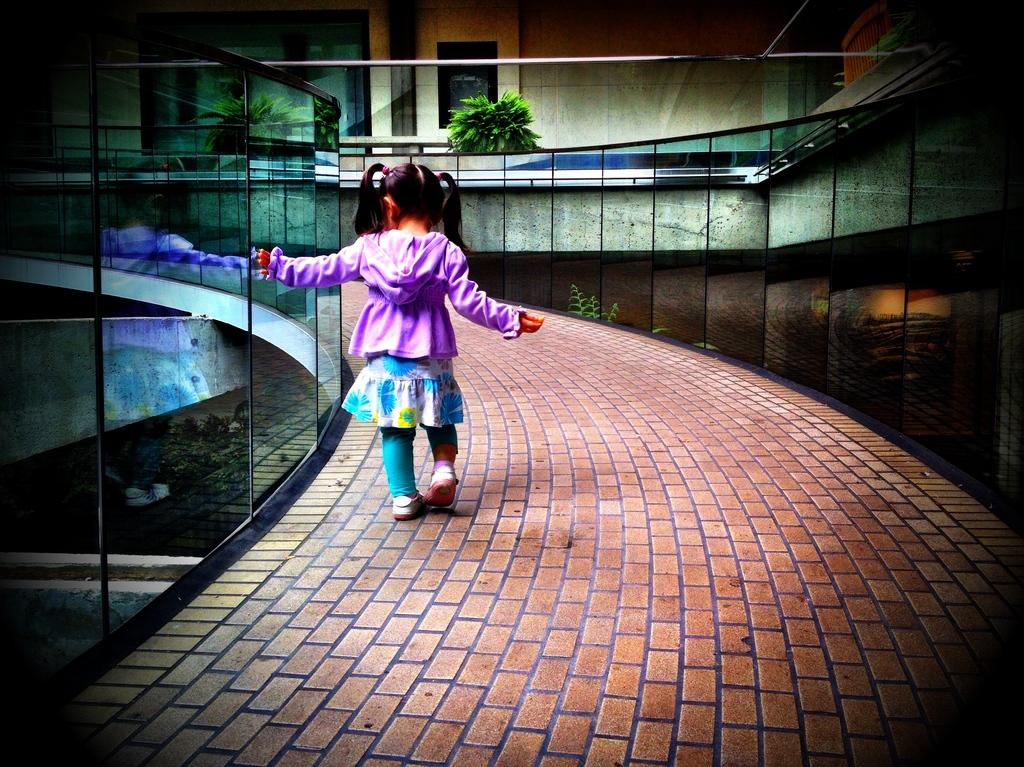What is the girl in the image doing? The girl is walking in the image. Where is the girl walking? The girl is on the road. What can be seen in the background of the image? There is a building and a plant in the background of the image. What architectural feature is present on either side of the road? There are mirror walls on either side of the road. Where is the soap located in the image? There is no soap present in the image. What type of throne can be seen in the image? There is no throne present in the image. 